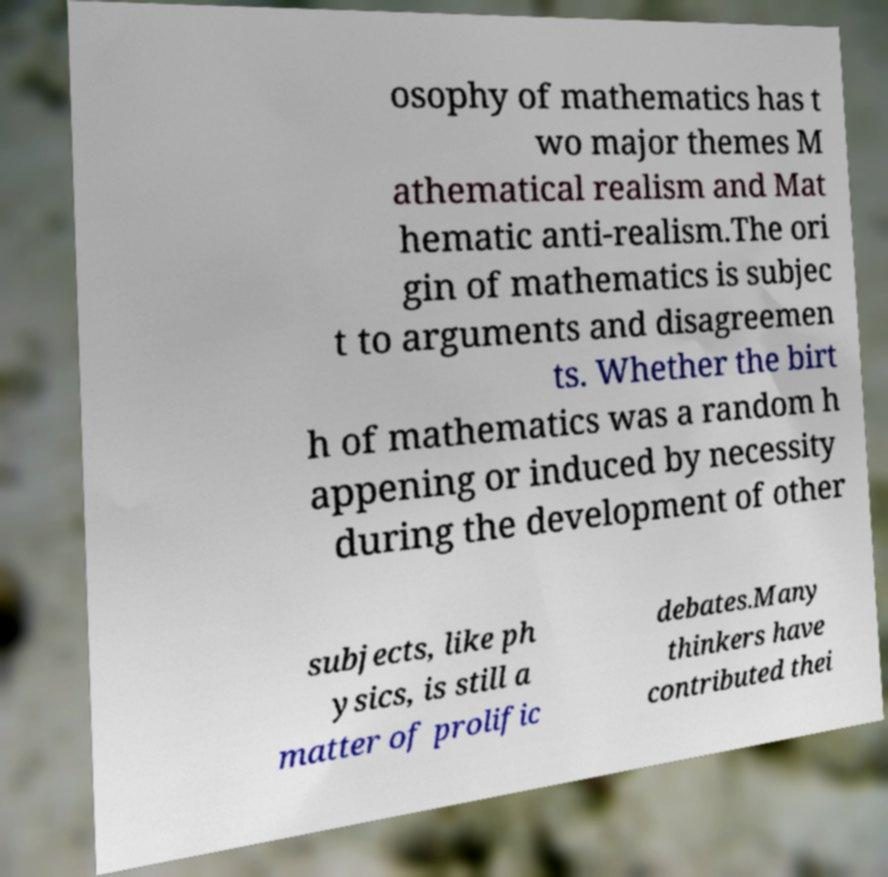For documentation purposes, I need the text within this image transcribed. Could you provide that? osophy of mathematics has t wo major themes M athematical realism and Mat hematic anti-realism.The ori gin of mathematics is subjec t to arguments and disagreemen ts. Whether the birt h of mathematics was a random h appening or induced by necessity during the development of other subjects, like ph ysics, is still a matter of prolific debates.Many thinkers have contributed thei 